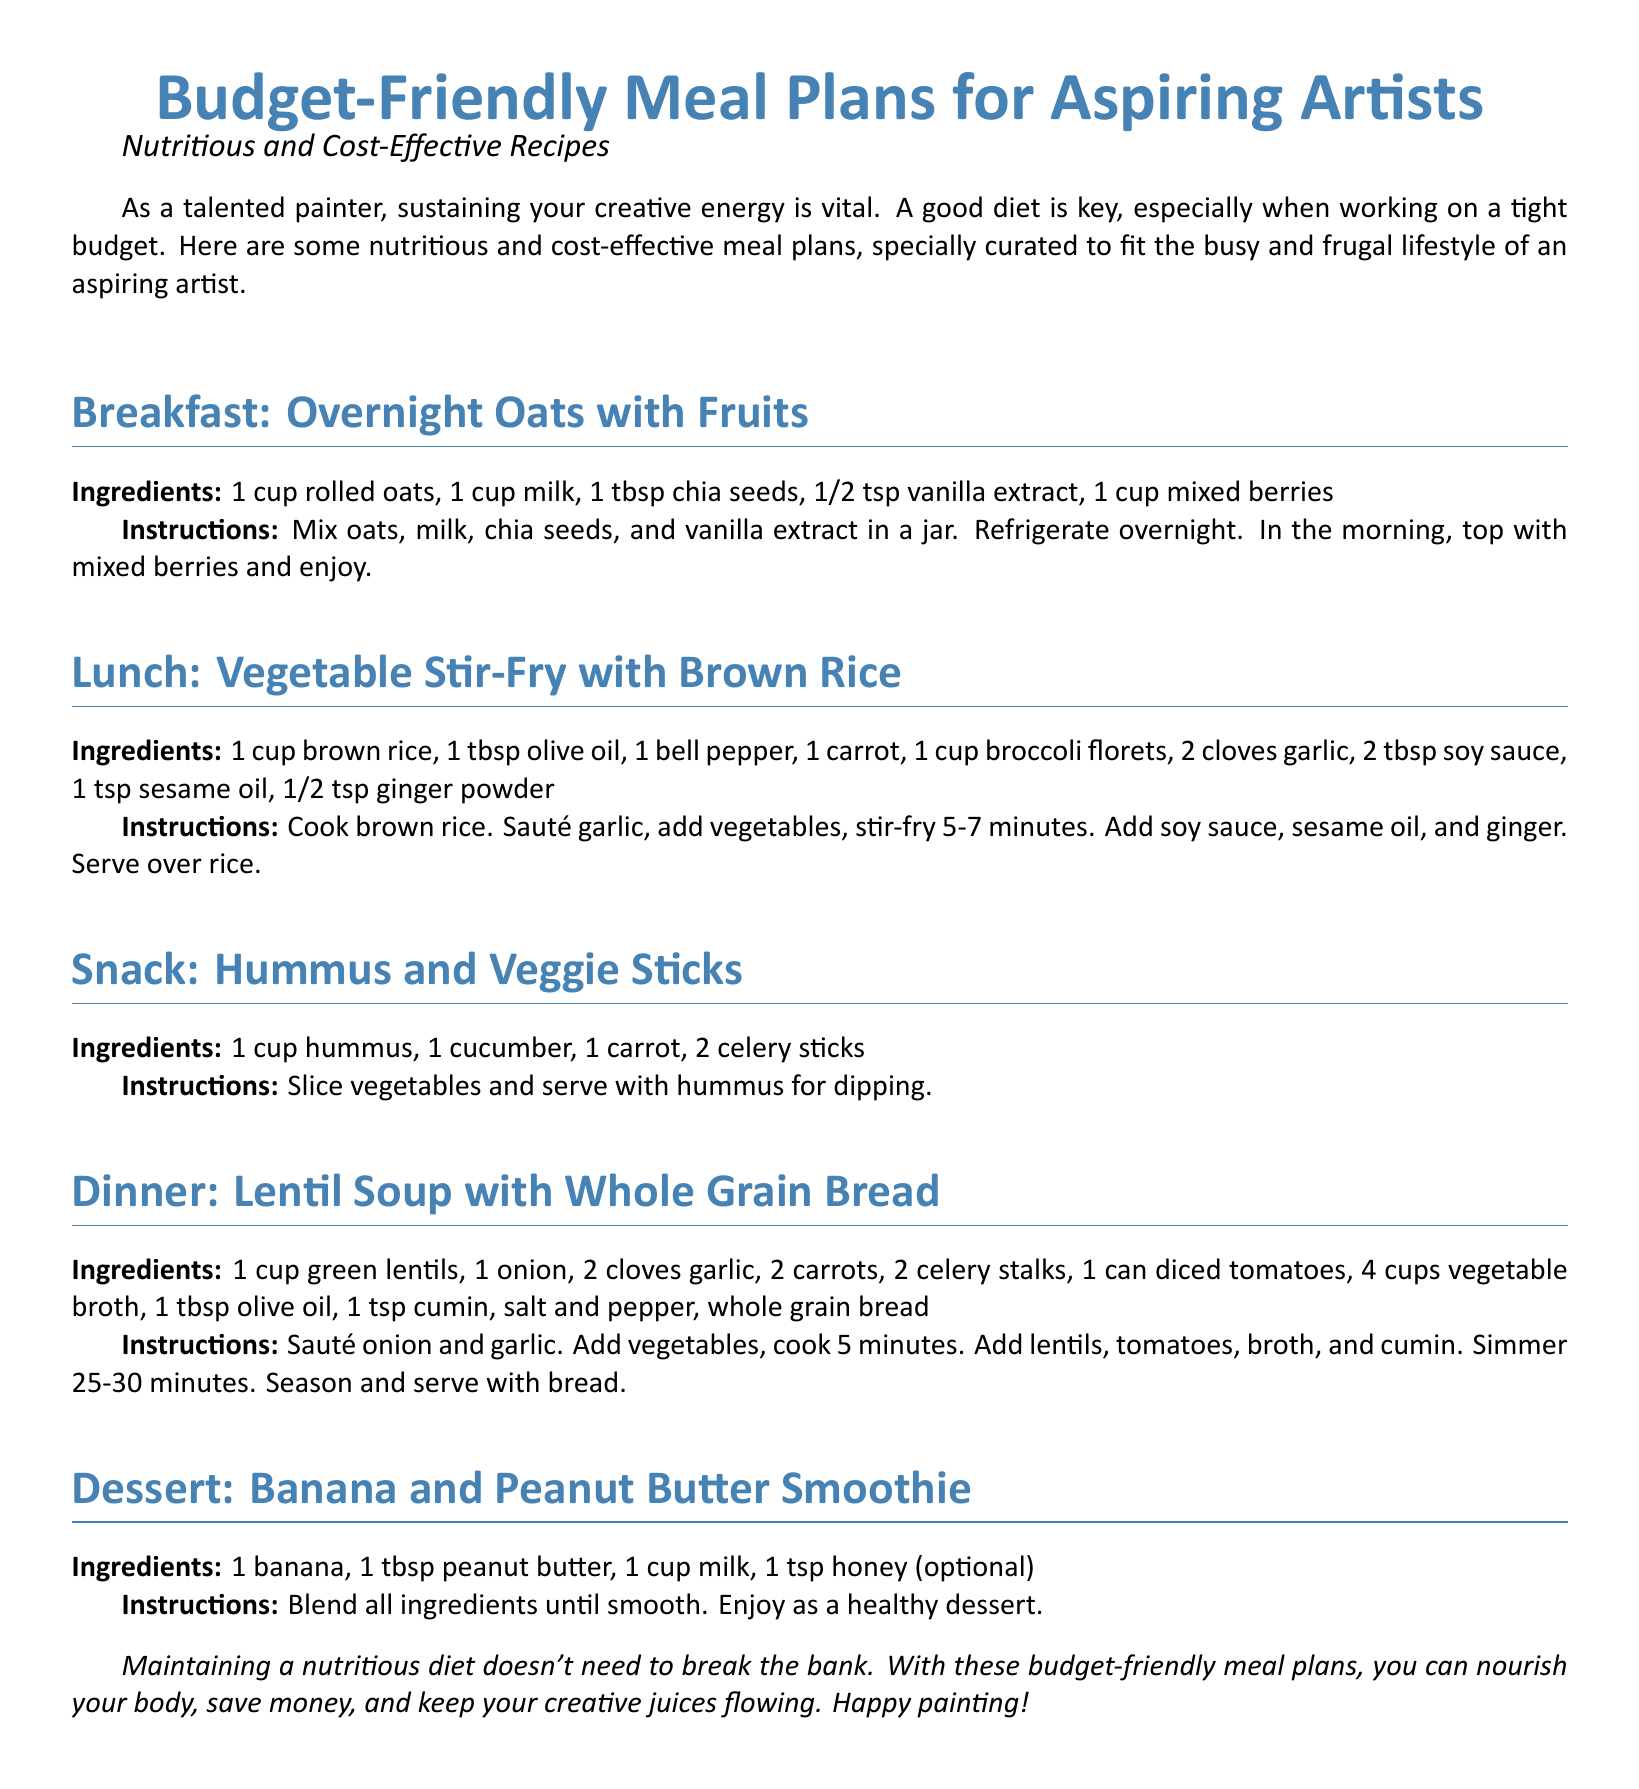What is the main theme of the document? The document revolves around providing budget-friendly meal plans for aspiring artists.
Answer: Budget-Friendly Meal Plans for Aspiring Artists How many servings does the Overnight Oats recipe make? The recipe does not specify servings but typically one cup of rolled oats provides one serving.
Answer: 1 serving What ingredient is used in the Vegetable Stir-Fry that adds flavor? Garlic is listed as an ingredient that enhances the flavor in the stir-fry.
Answer: Garlic What is the primary protein source in the Dinner recipe? Green lentils serve as the primary protein source in the lentil soup.
Answer: Green lentils What optional ingredient can be added to the Banana and Peanut Butter Smoothie? Honey is mentioned as an optional ingredient for the smoothie.
Answer: Honey How long should the lentil soup be simmered? The instructions state that the soup should be simmered for 25-30 minutes.
Answer: 25-30 minutes What type of bread is served with the lentil soup? Whole grain bread is specified to be served alongside the soup.
Answer: Whole grain bread What type of milk is used in the Overnight Oats recipe? The recipe refers to one cup of milk but does not specify the type; it is generally assumed to be any available milk.
Answer: Milk What is one of the snacks mentioned in the plan? The document includes hummus and veggie sticks as a snack option.
Answer: Hummus and Veggie Sticks 